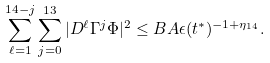<formula> <loc_0><loc_0><loc_500><loc_500>\sum _ { \ell = 1 } ^ { 1 4 - j } \sum _ { j = 0 } ^ { 1 3 } | D ^ { \ell } \Gamma ^ { j } \Phi | ^ { 2 } \leq B A \epsilon ( t ^ { * } ) ^ { - 1 + \eta _ { 1 4 } } .</formula> 